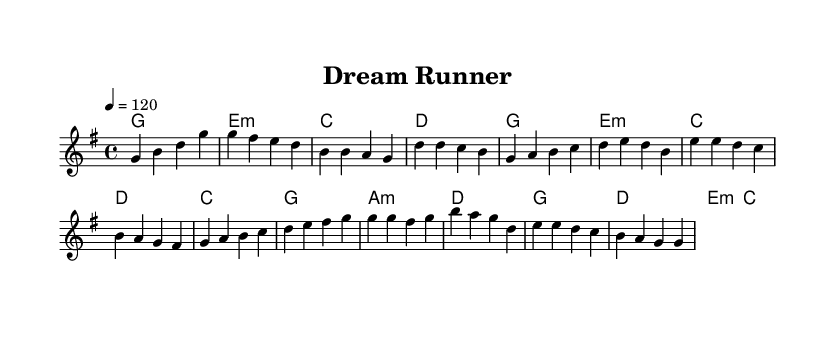What is the key signature of this music? The key signature is G major, which has one sharp (F#). This can be found in the global settings where the key is defined.
Answer: G major What is the time signature of this music? The time signature is 4/4, as indicated in the global settings where the time signature is specified.
Answer: 4/4 What is the tempo marking for this piece? The tempo is set at 120 beats per minute, as shown by the "tempo 4 = 120" in the global settings.
Answer: 120 How many measures are in the chorus section? The chorus section has four measures, which can be counted directly from the notation provided for the chorus in the code.
Answer: 4 What type of chords are primarily used in the harmonies section? The primary chords used are major and minor chords, as indicated by the chord names such as G major, E minor, and C major present in the harmonies.
Answer: Major and minor chords What is the structure of the song based on the sections provided? The structure includes an intro, verse, pre-chorus, and chorus, as indicated by the labeled sections within the melody and harmonies.
Answer: Intro, Verse, Pre-chorus, Chorus 